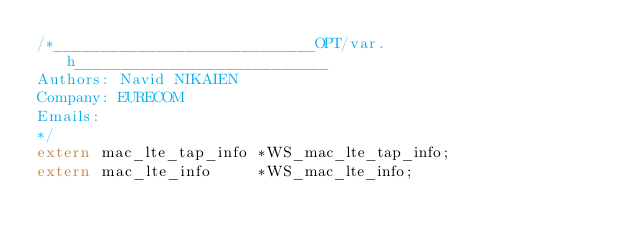Convert code to text. <code><loc_0><loc_0><loc_500><loc_500><_C_>/*____________________________OPT/var.h___________________________
Authors: Navid NIKAIEN
Company: EURECOM
Emails:
*/
extern mac_lte_tap_info *WS_mac_lte_tap_info;
extern mac_lte_info     *WS_mac_lte_info;
</code> 